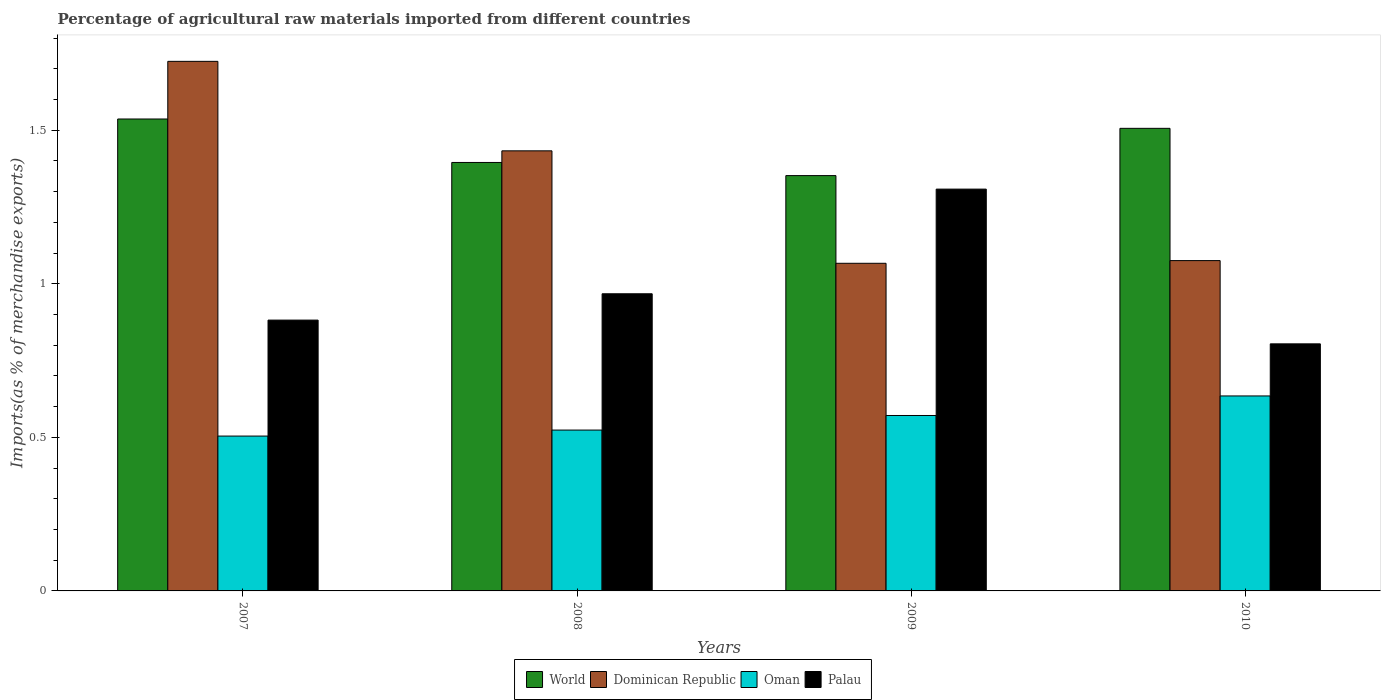How many groups of bars are there?
Provide a succinct answer. 4. How many bars are there on the 3rd tick from the left?
Keep it short and to the point. 4. What is the label of the 1st group of bars from the left?
Make the answer very short. 2007. What is the percentage of imports to different countries in Dominican Republic in 2010?
Your response must be concise. 1.08. Across all years, what is the maximum percentage of imports to different countries in Oman?
Your answer should be compact. 0.63. Across all years, what is the minimum percentage of imports to different countries in Oman?
Your response must be concise. 0.5. In which year was the percentage of imports to different countries in Palau maximum?
Ensure brevity in your answer.  2009. What is the total percentage of imports to different countries in Oman in the graph?
Ensure brevity in your answer.  2.23. What is the difference between the percentage of imports to different countries in World in 2007 and that in 2009?
Ensure brevity in your answer.  0.18. What is the difference between the percentage of imports to different countries in Oman in 2010 and the percentage of imports to different countries in Dominican Republic in 2009?
Ensure brevity in your answer.  -0.43. What is the average percentage of imports to different countries in Dominican Republic per year?
Make the answer very short. 1.32. In the year 2010, what is the difference between the percentage of imports to different countries in Dominican Republic and percentage of imports to different countries in World?
Make the answer very short. -0.43. What is the ratio of the percentage of imports to different countries in World in 2007 to that in 2010?
Give a very brief answer. 1.02. Is the difference between the percentage of imports to different countries in Dominican Republic in 2009 and 2010 greater than the difference between the percentage of imports to different countries in World in 2009 and 2010?
Keep it short and to the point. Yes. What is the difference between the highest and the second highest percentage of imports to different countries in Dominican Republic?
Your response must be concise. 0.29. What is the difference between the highest and the lowest percentage of imports to different countries in World?
Give a very brief answer. 0.18. In how many years, is the percentage of imports to different countries in Dominican Republic greater than the average percentage of imports to different countries in Dominican Republic taken over all years?
Offer a terse response. 2. Is the sum of the percentage of imports to different countries in World in 2008 and 2009 greater than the maximum percentage of imports to different countries in Palau across all years?
Your answer should be very brief. Yes. Is it the case that in every year, the sum of the percentage of imports to different countries in Palau and percentage of imports to different countries in World is greater than the sum of percentage of imports to different countries in Dominican Republic and percentage of imports to different countries in Oman?
Your response must be concise. No. What does the 2nd bar from the left in 2009 represents?
Provide a succinct answer. Dominican Republic. Is it the case that in every year, the sum of the percentage of imports to different countries in World and percentage of imports to different countries in Palau is greater than the percentage of imports to different countries in Dominican Republic?
Give a very brief answer. Yes. How many years are there in the graph?
Your response must be concise. 4. Are the values on the major ticks of Y-axis written in scientific E-notation?
Ensure brevity in your answer.  No. Where does the legend appear in the graph?
Provide a short and direct response. Bottom center. How many legend labels are there?
Offer a terse response. 4. How are the legend labels stacked?
Your response must be concise. Horizontal. What is the title of the graph?
Provide a succinct answer. Percentage of agricultural raw materials imported from different countries. Does "Malaysia" appear as one of the legend labels in the graph?
Provide a succinct answer. No. What is the label or title of the Y-axis?
Your answer should be very brief. Imports(as % of merchandise exports). What is the Imports(as % of merchandise exports) in World in 2007?
Provide a short and direct response. 1.54. What is the Imports(as % of merchandise exports) of Dominican Republic in 2007?
Provide a succinct answer. 1.72. What is the Imports(as % of merchandise exports) of Oman in 2007?
Offer a very short reply. 0.5. What is the Imports(as % of merchandise exports) of Palau in 2007?
Provide a succinct answer. 0.88. What is the Imports(as % of merchandise exports) of World in 2008?
Your answer should be compact. 1.4. What is the Imports(as % of merchandise exports) in Dominican Republic in 2008?
Provide a succinct answer. 1.43. What is the Imports(as % of merchandise exports) in Oman in 2008?
Keep it short and to the point. 0.52. What is the Imports(as % of merchandise exports) of Palau in 2008?
Give a very brief answer. 0.97. What is the Imports(as % of merchandise exports) in World in 2009?
Make the answer very short. 1.35. What is the Imports(as % of merchandise exports) in Dominican Republic in 2009?
Offer a very short reply. 1.07. What is the Imports(as % of merchandise exports) in Oman in 2009?
Your answer should be very brief. 0.57. What is the Imports(as % of merchandise exports) in Palau in 2009?
Offer a very short reply. 1.31. What is the Imports(as % of merchandise exports) of World in 2010?
Ensure brevity in your answer.  1.51. What is the Imports(as % of merchandise exports) in Dominican Republic in 2010?
Provide a succinct answer. 1.08. What is the Imports(as % of merchandise exports) of Oman in 2010?
Provide a succinct answer. 0.63. What is the Imports(as % of merchandise exports) in Palau in 2010?
Your answer should be compact. 0.8. Across all years, what is the maximum Imports(as % of merchandise exports) in World?
Make the answer very short. 1.54. Across all years, what is the maximum Imports(as % of merchandise exports) of Dominican Republic?
Offer a terse response. 1.72. Across all years, what is the maximum Imports(as % of merchandise exports) of Oman?
Provide a succinct answer. 0.63. Across all years, what is the maximum Imports(as % of merchandise exports) of Palau?
Ensure brevity in your answer.  1.31. Across all years, what is the minimum Imports(as % of merchandise exports) in World?
Keep it short and to the point. 1.35. Across all years, what is the minimum Imports(as % of merchandise exports) in Dominican Republic?
Offer a terse response. 1.07. Across all years, what is the minimum Imports(as % of merchandise exports) in Oman?
Make the answer very short. 0.5. Across all years, what is the minimum Imports(as % of merchandise exports) of Palau?
Your answer should be very brief. 0.8. What is the total Imports(as % of merchandise exports) in World in the graph?
Your answer should be very brief. 5.79. What is the total Imports(as % of merchandise exports) in Dominican Republic in the graph?
Keep it short and to the point. 5.3. What is the total Imports(as % of merchandise exports) in Oman in the graph?
Offer a terse response. 2.23. What is the total Imports(as % of merchandise exports) in Palau in the graph?
Provide a short and direct response. 3.96. What is the difference between the Imports(as % of merchandise exports) of World in 2007 and that in 2008?
Offer a terse response. 0.14. What is the difference between the Imports(as % of merchandise exports) of Dominican Republic in 2007 and that in 2008?
Your answer should be compact. 0.29. What is the difference between the Imports(as % of merchandise exports) in Oman in 2007 and that in 2008?
Make the answer very short. -0.02. What is the difference between the Imports(as % of merchandise exports) of Palau in 2007 and that in 2008?
Give a very brief answer. -0.09. What is the difference between the Imports(as % of merchandise exports) in World in 2007 and that in 2009?
Make the answer very short. 0.18. What is the difference between the Imports(as % of merchandise exports) in Dominican Republic in 2007 and that in 2009?
Ensure brevity in your answer.  0.66. What is the difference between the Imports(as % of merchandise exports) of Oman in 2007 and that in 2009?
Provide a short and direct response. -0.07. What is the difference between the Imports(as % of merchandise exports) in Palau in 2007 and that in 2009?
Your answer should be very brief. -0.43. What is the difference between the Imports(as % of merchandise exports) of World in 2007 and that in 2010?
Your answer should be compact. 0.03. What is the difference between the Imports(as % of merchandise exports) of Dominican Republic in 2007 and that in 2010?
Your response must be concise. 0.65. What is the difference between the Imports(as % of merchandise exports) in Oman in 2007 and that in 2010?
Provide a short and direct response. -0.13. What is the difference between the Imports(as % of merchandise exports) of Palau in 2007 and that in 2010?
Your response must be concise. 0.08. What is the difference between the Imports(as % of merchandise exports) in World in 2008 and that in 2009?
Provide a succinct answer. 0.04. What is the difference between the Imports(as % of merchandise exports) in Dominican Republic in 2008 and that in 2009?
Ensure brevity in your answer.  0.37. What is the difference between the Imports(as % of merchandise exports) of Oman in 2008 and that in 2009?
Ensure brevity in your answer.  -0.05. What is the difference between the Imports(as % of merchandise exports) of Palau in 2008 and that in 2009?
Provide a short and direct response. -0.34. What is the difference between the Imports(as % of merchandise exports) in World in 2008 and that in 2010?
Keep it short and to the point. -0.11. What is the difference between the Imports(as % of merchandise exports) in Dominican Republic in 2008 and that in 2010?
Keep it short and to the point. 0.36. What is the difference between the Imports(as % of merchandise exports) of Oman in 2008 and that in 2010?
Ensure brevity in your answer.  -0.11. What is the difference between the Imports(as % of merchandise exports) of Palau in 2008 and that in 2010?
Give a very brief answer. 0.16. What is the difference between the Imports(as % of merchandise exports) of World in 2009 and that in 2010?
Your answer should be compact. -0.15. What is the difference between the Imports(as % of merchandise exports) in Dominican Republic in 2009 and that in 2010?
Your answer should be compact. -0.01. What is the difference between the Imports(as % of merchandise exports) of Oman in 2009 and that in 2010?
Provide a succinct answer. -0.06. What is the difference between the Imports(as % of merchandise exports) in Palau in 2009 and that in 2010?
Ensure brevity in your answer.  0.5. What is the difference between the Imports(as % of merchandise exports) in World in 2007 and the Imports(as % of merchandise exports) in Dominican Republic in 2008?
Offer a terse response. 0.1. What is the difference between the Imports(as % of merchandise exports) in World in 2007 and the Imports(as % of merchandise exports) in Oman in 2008?
Keep it short and to the point. 1.01. What is the difference between the Imports(as % of merchandise exports) in World in 2007 and the Imports(as % of merchandise exports) in Palau in 2008?
Your answer should be compact. 0.57. What is the difference between the Imports(as % of merchandise exports) of Dominican Republic in 2007 and the Imports(as % of merchandise exports) of Oman in 2008?
Make the answer very short. 1.2. What is the difference between the Imports(as % of merchandise exports) of Dominican Republic in 2007 and the Imports(as % of merchandise exports) of Palau in 2008?
Give a very brief answer. 0.76. What is the difference between the Imports(as % of merchandise exports) in Oman in 2007 and the Imports(as % of merchandise exports) in Palau in 2008?
Your answer should be very brief. -0.46. What is the difference between the Imports(as % of merchandise exports) in World in 2007 and the Imports(as % of merchandise exports) in Dominican Republic in 2009?
Your response must be concise. 0.47. What is the difference between the Imports(as % of merchandise exports) in World in 2007 and the Imports(as % of merchandise exports) in Oman in 2009?
Provide a short and direct response. 0.97. What is the difference between the Imports(as % of merchandise exports) in World in 2007 and the Imports(as % of merchandise exports) in Palau in 2009?
Your answer should be very brief. 0.23. What is the difference between the Imports(as % of merchandise exports) in Dominican Republic in 2007 and the Imports(as % of merchandise exports) in Oman in 2009?
Provide a short and direct response. 1.15. What is the difference between the Imports(as % of merchandise exports) of Dominican Republic in 2007 and the Imports(as % of merchandise exports) of Palau in 2009?
Offer a very short reply. 0.42. What is the difference between the Imports(as % of merchandise exports) in Oman in 2007 and the Imports(as % of merchandise exports) in Palau in 2009?
Make the answer very short. -0.8. What is the difference between the Imports(as % of merchandise exports) in World in 2007 and the Imports(as % of merchandise exports) in Dominican Republic in 2010?
Your answer should be very brief. 0.46. What is the difference between the Imports(as % of merchandise exports) of World in 2007 and the Imports(as % of merchandise exports) of Oman in 2010?
Your answer should be very brief. 0.9. What is the difference between the Imports(as % of merchandise exports) in World in 2007 and the Imports(as % of merchandise exports) in Palau in 2010?
Your answer should be very brief. 0.73. What is the difference between the Imports(as % of merchandise exports) of Dominican Republic in 2007 and the Imports(as % of merchandise exports) of Oman in 2010?
Offer a terse response. 1.09. What is the difference between the Imports(as % of merchandise exports) in Dominican Republic in 2007 and the Imports(as % of merchandise exports) in Palau in 2010?
Your answer should be compact. 0.92. What is the difference between the Imports(as % of merchandise exports) in Oman in 2007 and the Imports(as % of merchandise exports) in Palau in 2010?
Your answer should be very brief. -0.3. What is the difference between the Imports(as % of merchandise exports) in World in 2008 and the Imports(as % of merchandise exports) in Dominican Republic in 2009?
Offer a terse response. 0.33. What is the difference between the Imports(as % of merchandise exports) of World in 2008 and the Imports(as % of merchandise exports) of Oman in 2009?
Ensure brevity in your answer.  0.82. What is the difference between the Imports(as % of merchandise exports) in World in 2008 and the Imports(as % of merchandise exports) in Palau in 2009?
Your answer should be compact. 0.09. What is the difference between the Imports(as % of merchandise exports) of Dominican Republic in 2008 and the Imports(as % of merchandise exports) of Oman in 2009?
Your response must be concise. 0.86. What is the difference between the Imports(as % of merchandise exports) of Dominican Republic in 2008 and the Imports(as % of merchandise exports) of Palau in 2009?
Give a very brief answer. 0.12. What is the difference between the Imports(as % of merchandise exports) in Oman in 2008 and the Imports(as % of merchandise exports) in Palau in 2009?
Ensure brevity in your answer.  -0.78. What is the difference between the Imports(as % of merchandise exports) of World in 2008 and the Imports(as % of merchandise exports) of Dominican Republic in 2010?
Offer a terse response. 0.32. What is the difference between the Imports(as % of merchandise exports) of World in 2008 and the Imports(as % of merchandise exports) of Oman in 2010?
Make the answer very short. 0.76. What is the difference between the Imports(as % of merchandise exports) in World in 2008 and the Imports(as % of merchandise exports) in Palau in 2010?
Your answer should be very brief. 0.59. What is the difference between the Imports(as % of merchandise exports) of Dominican Republic in 2008 and the Imports(as % of merchandise exports) of Oman in 2010?
Your answer should be compact. 0.8. What is the difference between the Imports(as % of merchandise exports) in Dominican Republic in 2008 and the Imports(as % of merchandise exports) in Palau in 2010?
Keep it short and to the point. 0.63. What is the difference between the Imports(as % of merchandise exports) of Oman in 2008 and the Imports(as % of merchandise exports) of Palau in 2010?
Offer a terse response. -0.28. What is the difference between the Imports(as % of merchandise exports) in World in 2009 and the Imports(as % of merchandise exports) in Dominican Republic in 2010?
Give a very brief answer. 0.28. What is the difference between the Imports(as % of merchandise exports) in World in 2009 and the Imports(as % of merchandise exports) in Oman in 2010?
Your answer should be very brief. 0.72. What is the difference between the Imports(as % of merchandise exports) in World in 2009 and the Imports(as % of merchandise exports) in Palau in 2010?
Provide a short and direct response. 0.55. What is the difference between the Imports(as % of merchandise exports) in Dominican Republic in 2009 and the Imports(as % of merchandise exports) in Oman in 2010?
Provide a short and direct response. 0.43. What is the difference between the Imports(as % of merchandise exports) in Dominican Republic in 2009 and the Imports(as % of merchandise exports) in Palau in 2010?
Provide a short and direct response. 0.26. What is the difference between the Imports(as % of merchandise exports) in Oman in 2009 and the Imports(as % of merchandise exports) in Palau in 2010?
Offer a terse response. -0.23. What is the average Imports(as % of merchandise exports) in World per year?
Keep it short and to the point. 1.45. What is the average Imports(as % of merchandise exports) in Dominican Republic per year?
Keep it short and to the point. 1.32. What is the average Imports(as % of merchandise exports) of Oman per year?
Offer a terse response. 0.56. In the year 2007, what is the difference between the Imports(as % of merchandise exports) in World and Imports(as % of merchandise exports) in Dominican Republic?
Your answer should be compact. -0.19. In the year 2007, what is the difference between the Imports(as % of merchandise exports) in World and Imports(as % of merchandise exports) in Oman?
Make the answer very short. 1.03. In the year 2007, what is the difference between the Imports(as % of merchandise exports) in World and Imports(as % of merchandise exports) in Palau?
Provide a succinct answer. 0.65. In the year 2007, what is the difference between the Imports(as % of merchandise exports) in Dominican Republic and Imports(as % of merchandise exports) in Oman?
Ensure brevity in your answer.  1.22. In the year 2007, what is the difference between the Imports(as % of merchandise exports) in Dominican Republic and Imports(as % of merchandise exports) in Palau?
Offer a terse response. 0.84. In the year 2007, what is the difference between the Imports(as % of merchandise exports) in Oman and Imports(as % of merchandise exports) in Palau?
Keep it short and to the point. -0.38. In the year 2008, what is the difference between the Imports(as % of merchandise exports) in World and Imports(as % of merchandise exports) in Dominican Republic?
Provide a succinct answer. -0.04. In the year 2008, what is the difference between the Imports(as % of merchandise exports) in World and Imports(as % of merchandise exports) in Oman?
Ensure brevity in your answer.  0.87. In the year 2008, what is the difference between the Imports(as % of merchandise exports) of World and Imports(as % of merchandise exports) of Palau?
Provide a succinct answer. 0.43. In the year 2008, what is the difference between the Imports(as % of merchandise exports) in Dominican Republic and Imports(as % of merchandise exports) in Palau?
Offer a very short reply. 0.47. In the year 2008, what is the difference between the Imports(as % of merchandise exports) of Oman and Imports(as % of merchandise exports) of Palau?
Ensure brevity in your answer.  -0.44. In the year 2009, what is the difference between the Imports(as % of merchandise exports) of World and Imports(as % of merchandise exports) of Dominican Republic?
Offer a terse response. 0.29. In the year 2009, what is the difference between the Imports(as % of merchandise exports) of World and Imports(as % of merchandise exports) of Oman?
Ensure brevity in your answer.  0.78. In the year 2009, what is the difference between the Imports(as % of merchandise exports) in World and Imports(as % of merchandise exports) in Palau?
Ensure brevity in your answer.  0.04. In the year 2009, what is the difference between the Imports(as % of merchandise exports) of Dominican Republic and Imports(as % of merchandise exports) of Oman?
Give a very brief answer. 0.5. In the year 2009, what is the difference between the Imports(as % of merchandise exports) in Dominican Republic and Imports(as % of merchandise exports) in Palau?
Provide a succinct answer. -0.24. In the year 2009, what is the difference between the Imports(as % of merchandise exports) of Oman and Imports(as % of merchandise exports) of Palau?
Your answer should be very brief. -0.74. In the year 2010, what is the difference between the Imports(as % of merchandise exports) of World and Imports(as % of merchandise exports) of Dominican Republic?
Your response must be concise. 0.43. In the year 2010, what is the difference between the Imports(as % of merchandise exports) in World and Imports(as % of merchandise exports) in Oman?
Make the answer very short. 0.87. In the year 2010, what is the difference between the Imports(as % of merchandise exports) of World and Imports(as % of merchandise exports) of Palau?
Give a very brief answer. 0.7. In the year 2010, what is the difference between the Imports(as % of merchandise exports) in Dominican Republic and Imports(as % of merchandise exports) in Oman?
Keep it short and to the point. 0.44. In the year 2010, what is the difference between the Imports(as % of merchandise exports) of Dominican Republic and Imports(as % of merchandise exports) of Palau?
Offer a terse response. 0.27. In the year 2010, what is the difference between the Imports(as % of merchandise exports) in Oman and Imports(as % of merchandise exports) in Palau?
Provide a succinct answer. -0.17. What is the ratio of the Imports(as % of merchandise exports) of World in 2007 to that in 2008?
Your answer should be compact. 1.1. What is the ratio of the Imports(as % of merchandise exports) of Dominican Republic in 2007 to that in 2008?
Your answer should be compact. 1.2. What is the ratio of the Imports(as % of merchandise exports) of Oman in 2007 to that in 2008?
Offer a very short reply. 0.96. What is the ratio of the Imports(as % of merchandise exports) of Palau in 2007 to that in 2008?
Your answer should be very brief. 0.91. What is the ratio of the Imports(as % of merchandise exports) of World in 2007 to that in 2009?
Your response must be concise. 1.14. What is the ratio of the Imports(as % of merchandise exports) of Dominican Republic in 2007 to that in 2009?
Offer a terse response. 1.62. What is the ratio of the Imports(as % of merchandise exports) in Oman in 2007 to that in 2009?
Offer a terse response. 0.88. What is the ratio of the Imports(as % of merchandise exports) of Palau in 2007 to that in 2009?
Your answer should be very brief. 0.67. What is the ratio of the Imports(as % of merchandise exports) in World in 2007 to that in 2010?
Keep it short and to the point. 1.02. What is the ratio of the Imports(as % of merchandise exports) in Dominican Republic in 2007 to that in 2010?
Ensure brevity in your answer.  1.6. What is the ratio of the Imports(as % of merchandise exports) in Oman in 2007 to that in 2010?
Give a very brief answer. 0.79. What is the ratio of the Imports(as % of merchandise exports) of Palau in 2007 to that in 2010?
Give a very brief answer. 1.1. What is the ratio of the Imports(as % of merchandise exports) in World in 2008 to that in 2009?
Give a very brief answer. 1.03. What is the ratio of the Imports(as % of merchandise exports) of Dominican Republic in 2008 to that in 2009?
Keep it short and to the point. 1.34. What is the ratio of the Imports(as % of merchandise exports) in Oman in 2008 to that in 2009?
Make the answer very short. 0.92. What is the ratio of the Imports(as % of merchandise exports) of Palau in 2008 to that in 2009?
Make the answer very short. 0.74. What is the ratio of the Imports(as % of merchandise exports) in World in 2008 to that in 2010?
Offer a terse response. 0.93. What is the ratio of the Imports(as % of merchandise exports) of Dominican Republic in 2008 to that in 2010?
Ensure brevity in your answer.  1.33. What is the ratio of the Imports(as % of merchandise exports) in Oman in 2008 to that in 2010?
Ensure brevity in your answer.  0.82. What is the ratio of the Imports(as % of merchandise exports) of Palau in 2008 to that in 2010?
Your answer should be very brief. 1.2. What is the ratio of the Imports(as % of merchandise exports) of World in 2009 to that in 2010?
Your answer should be very brief. 0.9. What is the ratio of the Imports(as % of merchandise exports) in Dominican Republic in 2009 to that in 2010?
Your answer should be very brief. 0.99. What is the ratio of the Imports(as % of merchandise exports) of Oman in 2009 to that in 2010?
Make the answer very short. 0.9. What is the ratio of the Imports(as % of merchandise exports) of Palau in 2009 to that in 2010?
Your answer should be compact. 1.63. What is the difference between the highest and the second highest Imports(as % of merchandise exports) in World?
Your answer should be very brief. 0.03. What is the difference between the highest and the second highest Imports(as % of merchandise exports) of Dominican Republic?
Your answer should be very brief. 0.29. What is the difference between the highest and the second highest Imports(as % of merchandise exports) of Oman?
Ensure brevity in your answer.  0.06. What is the difference between the highest and the second highest Imports(as % of merchandise exports) in Palau?
Keep it short and to the point. 0.34. What is the difference between the highest and the lowest Imports(as % of merchandise exports) in World?
Your answer should be very brief. 0.18. What is the difference between the highest and the lowest Imports(as % of merchandise exports) in Dominican Republic?
Ensure brevity in your answer.  0.66. What is the difference between the highest and the lowest Imports(as % of merchandise exports) in Oman?
Provide a succinct answer. 0.13. What is the difference between the highest and the lowest Imports(as % of merchandise exports) of Palau?
Ensure brevity in your answer.  0.5. 